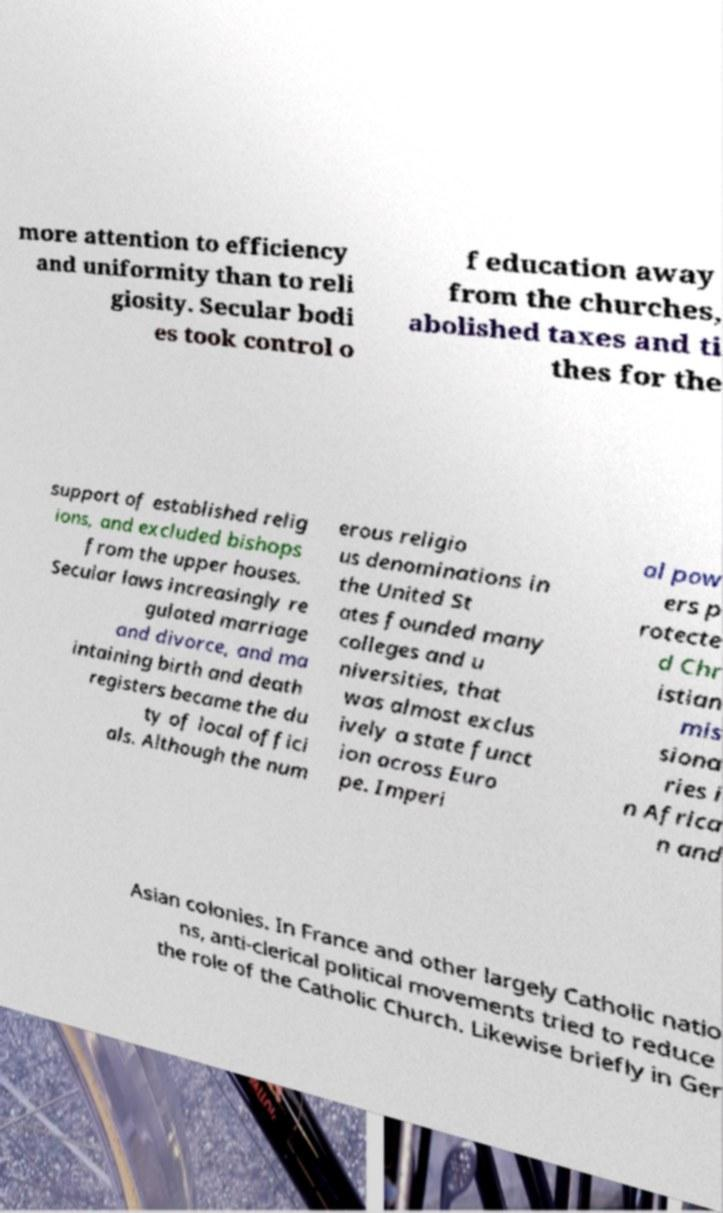For documentation purposes, I need the text within this image transcribed. Could you provide that? more attention to efficiency and uniformity than to reli giosity. Secular bodi es took control o f education away from the churches, abolished taxes and ti thes for the support of established relig ions, and excluded bishops from the upper houses. Secular laws increasingly re gulated marriage and divorce, and ma intaining birth and death registers became the du ty of local offici als. Although the num erous religio us denominations in the United St ates founded many colleges and u niversities, that was almost exclus ively a state funct ion across Euro pe. Imperi al pow ers p rotecte d Chr istian mis siona ries i n Africa n and Asian colonies. In France and other largely Catholic natio ns, anti-clerical political movements tried to reduce the role of the Catholic Church. Likewise briefly in Ger 